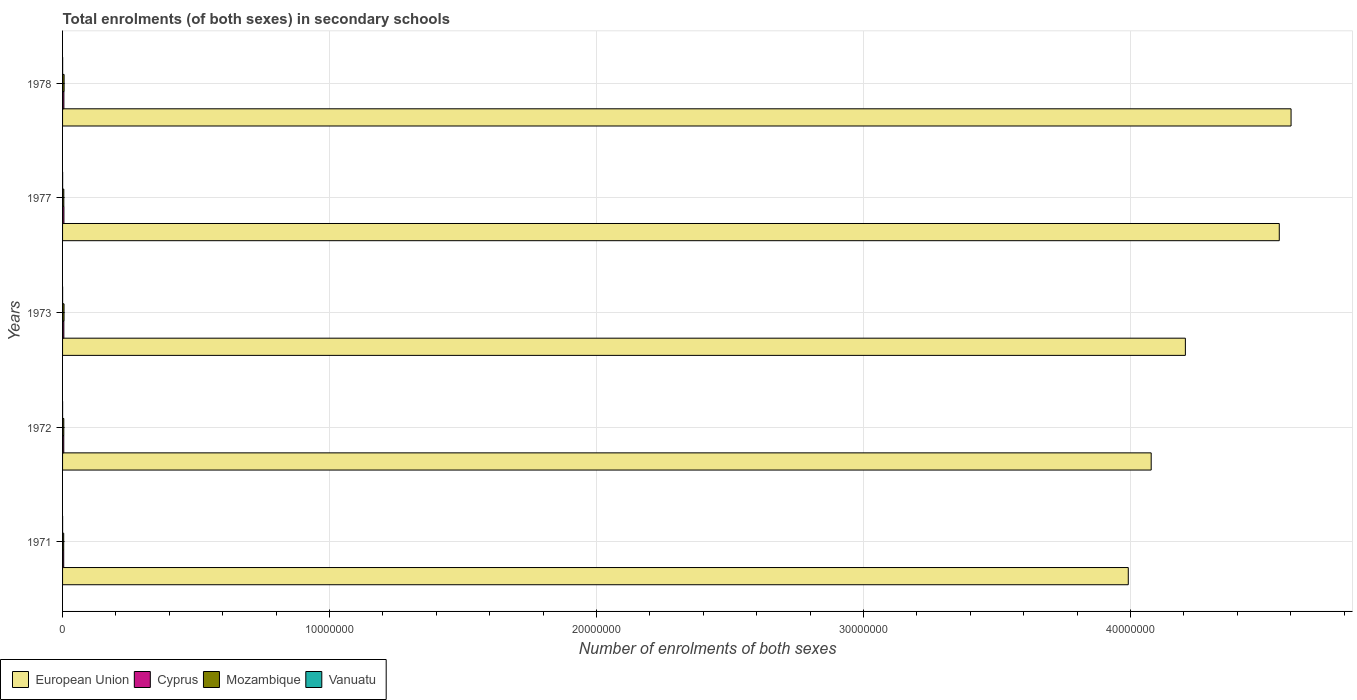How many different coloured bars are there?
Your response must be concise. 4. Are the number of bars per tick equal to the number of legend labels?
Give a very brief answer. Yes. What is the label of the 4th group of bars from the top?
Keep it short and to the point. 1972. What is the number of enrolments in secondary schools in European Union in 1971?
Provide a succinct answer. 3.99e+07. Across all years, what is the maximum number of enrolments in secondary schools in Cyprus?
Give a very brief answer. 5.06e+04. Across all years, what is the minimum number of enrolments in secondary schools in Mozambique?
Offer a terse response. 4.29e+04. In which year was the number of enrolments in secondary schools in Cyprus maximum?
Offer a very short reply. 1977. In which year was the number of enrolments in secondary schools in Mozambique minimum?
Provide a succinct answer. 1971. What is the total number of enrolments in secondary schools in European Union in the graph?
Offer a terse response. 2.14e+08. What is the difference between the number of enrolments in secondary schools in European Union in 1971 and that in 1978?
Offer a terse response. -6.10e+06. What is the difference between the number of enrolments in secondary schools in Cyprus in 1978 and the number of enrolments in secondary schools in European Union in 1973?
Offer a very short reply. -4.20e+07. What is the average number of enrolments in secondary schools in Cyprus per year?
Provide a short and direct response. 4.71e+04. In the year 1977, what is the difference between the number of enrolments in secondary schools in European Union and number of enrolments in secondary schools in Vanuatu?
Give a very brief answer. 4.56e+07. In how many years, is the number of enrolments in secondary schools in Vanuatu greater than 38000000 ?
Keep it short and to the point. 0. What is the ratio of the number of enrolments in secondary schools in Mozambique in 1971 to that in 1972?
Provide a short and direct response. 0.93. Is the number of enrolments in secondary schools in European Union in 1971 less than that in 1973?
Your answer should be compact. Yes. Is the difference between the number of enrolments in secondary schools in European Union in 1972 and 1978 greater than the difference between the number of enrolments in secondary schools in Vanuatu in 1972 and 1978?
Give a very brief answer. No. What is the difference between the highest and the second highest number of enrolments in secondary schools in Cyprus?
Your answer should be very brief. 1275. What is the difference between the highest and the lowest number of enrolments in secondary schools in Cyprus?
Offer a very short reply. 8328. Is the sum of the number of enrolments in secondary schools in Mozambique in 1977 and 1978 greater than the maximum number of enrolments in secondary schools in Cyprus across all years?
Keep it short and to the point. Yes. What does the 2nd bar from the bottom in 1972 represents?
Give a very brief answer. Cyprus. Is it the case that in every year, the sum of the number of enrolments in secondary schools in Mozambique and number of enrolments in secondary schools in Cyprus is greater than the number of enrolments in secondary schools in Vanuatu?
Ensure brevity in your answer.  Yes. Are all the bars in the graph horizontal?
Your answer should be very brief. Yes. Does the graph contain any zero values?
Ensure brevity in your answer.  No. Where does the legend appear in the graph?
Offer a terse response. Bottom left. How many legend labels are there?
Make the answer very short. 4. What is the title of the graph?
Give a very brief answer. Total enrolments (of both sexes) in secondary schools. What is the label or title of the X-axis?
Keep it short and to the point. Number of enrolments of both sexes. What is the label or title of the Y-axis?
Your response must be concise. Years. What is the Number of enrolments of both sexes in European Union in 1971?
Offer a terse response. 3.99e+07. What is the Number of enrolments of both sexes in Cyprus in 1971?
Make the answer very short. 4.23e+04. What is the Number of enrolments of both sexes in Mozambique in 1971?
Keep it short and to the point. 4.29e+04. What is the Number of enrolments of both sexes of Vanuatu in 1971?
Offer a very short reply. 878. What is the Number of enrolments of both sexes in European Union in 1972?
Keep it short and to the point. 4.08e+07. What is the Number of enrolments of both sexes in Cyprus in 1972?
Your answer should be very brief. 4.50e+04. What is the Number of enrolments of both sexes in Mozambique in 1972?
Your response must be concise. 4.61e+04. What is the Number of enrolments of both sexes of Vanuatu in 1972?
Provide a succinct answer. 980. What is the Number of enrolments of both sexes in European Union in 1973?
Your answer should be compact. 4.21e+07. What is the Number of enrolments of both sexes in Cyprus in 1973?
Ensure brevity in your answer.  4.81e+04. What is the Number of enrolments of both sexes in Mozambique in 1973?
Offer a terse response. 5.46e+04. What is the Number of enrolments of both sexes in Vanuatu in 1973?
Keep it short and to the point. 1089. What is the Number of enrolments of both sexes of European Union in 1977?
Make the answer very short. 4.56e+07. What is the Number of enrolments of both sexes of Cyprus in 1977?
Your response must be concise. 5.06e+04. What is the Number of enrolments of both sexes of Mozambique in 1977?
Offer a terse response. 4.67e+04. What is the Number of enrolments of both sexes of Vanuatu in 1977?
Provide a short and direct response. 2127. What is the Number of enrolments of both sexes in European Union in 1978?
Provide a short and direct response. 4.60e+07. What is the Number of enrolments of both sexes of Cyprus in 1978?
Make the answer very short. 4.94e+04. What is the Number of enrolments of both sexes of Mozambique in 1978?
Provide a short and direct response. 5.73e+04. What is the Number of enrolments of both sexes in Vanuatu in 1978?
Offer a terse response. 2284. Across all years, what is the maximum Number of enrolments of both sexes in European Union?
Your response must be concise. 4.60e+07. Across all years, what is the maximum Number of enrolments of both sexes of Cyprus?
Provide a succinct answer. 5.06e+04. Across all years, what is the maximum Number of enrolments of both sexes of Mozambique?
Keep it short and to the point. 5.73e+04. Across all years, what is the maximum Number of enrolments of both sexes in Vanuatu?
Your answer should be very brief. 2284. Across all years, what is the minimum Number of enrolments of both sexes of European Union?
Ensure brevity in your answer.  3.99e+07. Across all years, what is the minimum Number of enrolments of both sexes of Cyprus?
Provide a succinct answer. 4.23e+04. Across all years, what is the minimum Number of enrolments of both sexes in Mozambique?
Your response must be concise. 4.29e+04. Across all years, what is the minimum Number of enrolments of both sexes of Vanuatu?
Your answer should be very brief. 878. What is the total Number of enrolments of both sexes in European Union in the graph?
Keep it short and to the point. 2.14e+08. What is the total Number of enrolments of both sexes in Cyprus in the graph?
Make the answer very short. 2.35e+05. What is the total Number of enrolments of both sexes in Mozambique in the graph?
Your answer should be compact. 2.48e+05. What is the total Number of enrolments of both sexes of Vanuatu in the graph?
Ensure brevity in your answer.  7358. What is the difference between the Number of enrolments of both sexes of European Union in 1971 and that in 1972?
Give a very brief answer. -8.58e+05. What is the difference between the Number of enrolments of both sexes of Cyprus in 1971 and that in 1972?
Keep it short and to the point. -2736. What is the difference between the Number of enrolments of both sexes of Mozambique in 1971 and that in 1972?
Keep it short and to the point. -3260. What is the difference between the Number of enrolments of both sexes of Vanuatu in 1971 and that in 1972?
Offer a terse response. -102. What is the difference between the Number of enrolments of both sexes of European Union in 1971 and that in 1973?
Your response must be concise. -2.14e+06. What is the difference between the Number of enrolments of both sexes of Cyprus in 1971 and that in 1973?
Ensure brevity in your answer.  -5764. What is the difference between the Number of enrolments of both sexes of Mozambique in 1971 and that in 1973?
Ensure brevity in your answer.  -1.18e+04. What is the difference between the Number of enrolments of both sexes of Vanuatu in 1971 and that in 1973?
Offer a very short reply. -211. What is the difference between the Number of enrolments of both sexes of European Union in 1971 and that in 1977?
Keep it short and to the point. -5.66e+06. What is the difference between the Number of enrolments of both sexes in Cyprus in 1971 and that in 1977?
Provide a short and direct response. -8328. What is the difference between the Number of enrolments of both sexes in Mozambique in 1971 and that in 1977?
Make the answer very short. -3788. What is the difference between the Number of enrolments of both sexes in Vanuatu in 1971 and that in 1977?
Your answer should be very brief. -1249. What is the difference between the Number of enrolments of both sexes of European Union in 1971 and that in 1978?
Provide a succinct answer. -6.10e+06. What is the difference between the Number of enrolments of both sexes in Cyprus in 1971 and that in 1978?
Your answer should be compact. -7053. What is the difference between the Number of enrolments of both sexes of Mozambique in 1971 and that in 1978?
Provide a succinct answer. -1.44e+04. What is the difference between the Number of enrolments of both sexes of Vanuatu in 1971 and that in 1978?
Ensure brevity in your answer.  -1406. What is the difference between the Number of enrolments of both sexes of European Union in 1972 and that in 1973?
Provide a succinct answer. -1.28e+06. What is the difference between the Number of enrolments of both sexes in Cyprus in 1972 and that in 1973?
Your answer should be very brief. -3028. What is the difference between the Number of enrolments of both sexes in Mozambique in 1972 and that in 1973?
Offer a terse response. -8522. What is the difference between the Number of enrolments of both sexes in Vanuatu in 1972 and that in 1973?
Your response must be concise. -109. What is the difference between the Number of enrolments of both sexes of European Union in 1972 and that in 1977?
Ensure brevity in your answer.  -4.80e+06. What is the difference between the Number of enrolments of both sexes in Cyprus in 1972 and that in 1977?
Give a very brief answer. -5592. What is the difference between the Number of enrolments of both sexes of Mozambique in 1972 and that in 1977?
Provide a succinct answer. -528. What is the difference between the Number of enrolments of both sexes of Vanuatu in 1972 and that in 1977?
Your answer should be compact. -1147. What is the difference between the Number of enrolments of both sexes of European Union in 1972 and that in 1978?
Make the answer very short. -5.24e+06. What is the difference between the Number of enrolments of both sexes of Cyprus in 1972 and that in 1978?
Your answer should be compact. -4317. What is the difference between the Number of enrolments of both sexes in Mozambique in 1972 and that in 1978?
Give a very brief answer. -1.12e+04. What is the difference between the Number of enrolments of both sexes in Vanuatu in 1972 and that in 1978?
Provide a short and direct response. -1304. What is the difference between the Number of enrolments of both sexes in European Union in 1973 and that in 1977?
Make the answer very short. -3.52e+06. What is the difference between the Number of enrolments of both sexes in Cyprus in 1973 and that in 1977?
Your response must be concise. -2564. What is the difference between the Number of enrolments of both sexes of Mozambique in 1973 and that in 1977?
Offer a very short reply. 7994. What is the difference between the Number of enrolments of both sexes in Vanuatu in 1973 and that in 1977?
Offer a terse response. -1038. What is the difference between the Number of enrolments of both sexes of European Union in 1973 and that in 1978?
Offer a terse response. -3.96e+06. What is the difference between the Number of enrolments of both sexes of Cyprus in 1973 and that in 1978?
Give a very brief answer. -1289. What is the difference between the Number of enrolments of both sexes of Mozambique in 1973 and that in 1978?
Give a very brief answer. -2650. What is the difference between the Number of enrolments of both sexes of Vanuatu in 1973 and that in 1978?
Make the answer very short. -1195. What is the difference between the Number of enrolments of both sexes in European Union in 1977 and that in 1978?
Provide a succinct answer. -4.41e+05. What is the difference between the Number of enrolments of both sexes of Cyprus in 1977 and that in 1978?
Provide a succinct answer. 1275. What is the difference between the Number of enrolments of both sexes of Mozambique in 1977 and that in 1978?
Ensure brevity in your answer.  -1.06e+04. What is the difference between the Number of enrolments of both sexes in Vanuatu in 1977 and that in 1978?
Offer a terse response. -157. What is the difference between the Number of enrolments of both sexes in European Union in 1971 and the Number of enrolments of both sexes in Cyprus in 1972?
Give a very brief answer. 3.99e+07. What is the difference between the Number of enrolments of both sexes of European Union in 1971 and the Number of enrolments of both sexes of Mozambique in 1972?
Give a very brief answer. 3.99e+07. What is the difference between the Number of enrolments of both sexes in European Union in 1971 and the Number of enrolments of both sexes in Vanuatu in 1972?
Provide a short and direct response. 3.99e+07. What is the difference between the Number of enrolments of both sexes of Cyprus in 1971 and the Number of enrolments of both sexes of Mozambique in 1972?
Keep it short and to the point. -3823. What is the difference between the Number of enrolments of both sexes of Cyprus in 1971 and the Number of enrolments of both sexes of Vanuatu in 1972?
Your response must be concise. 4.13e+04. What is the difference between the Number of enrolments of both sexes of Mozambique in 1971 and the Number of enrolments of both sexes of Vanuatu in 1972?
Your answer should be compact. 4.19e+04. What is the difference between the Number of enrolments of both sexes in European Union in 1971 and the Number of enrolments of both sexes in Cyprus in 1973?
Offer a terse response. 3.99e+07. What is the difference between the Number of enrolments of both sexes in European Union in 1971 and the Number of enrolments of both sexes in Mozambique in 1973?
Provide a short and direct response. 3.99e+07. What is the difference between the Number of enrolments of both sexes of European Union in 1971 and the Number of enrolments of both sexes of Vanuatu in 1973?
Your response must be concise. 3.99e+07. What is the difference between the Number of enrolments of both sexes in Cyprus in 1971 and the Number of enrolments of both sexes in Mozambique in 1973?
Ensure brevity in your answer.  -1.23e+04. What is the difference between the Number of enrolments of both sexes of Cyprus in 1971 and the Number of enrolments of both sexes of Vanuatu in 1973?
Your answer should be very brief. 4.12e+04. What is the difference between the Number of enrolments of both sexes in Mozambique in 1971 and the Number of enrolments of both sexes in Vanuatu in 1973?
Provide a succinct answer. 4.18e+04. What is the difference between the Number of enrolments of both sexes in European Union in 1971 and the Number of enrolments of both sexes in Cyprus in 1977?
Your answer should be compact. 3.99e+07. What is the difference between the Number of enrolments of both sexes in European Union in 1971 and the Number of enrolments of both sexes in Mozambique in 1977?
Your response must be concise. 3.99e+07. What is the difference between the Number of enrolments of both sexes of European Union in 1971 and the Number of enrolments of both sexes of Vanuatu in 1977?
Offer a very short reply. 3.99e+07. What is the difference between the Number of enrolments of both sexes in Cyprus in 1971 and the Number of enrolments of both sexes in Mozambique in 1977?
Provide a short and direct response. -4351. What is the difference between the Number of enrolments of both sexes in Cyprus in 1971 and the Number of enrolments of both sexes in Vanuatu in 1977?
Your answer should be very brief. 4.02e+04. What is the difference between the Number of enrolments of both sexes in Mozambique in 1971 and the Number of enrolments of both sexes in Vanuatu in 1977?
Provide a succinct answer. 4.07e+04. What is the difference between the Number of enrolments of both sexes of European Union in 1971 and the Number of enrolments of both sexes of Cyprus in 1978?
Ensure brevity in your answer.  3.99e+07. What is the difference between the Number of enrolments of both sexes of European Union in 1971 and the Number of enrolments of both sexes of Mozambique in 1978?
Keep it short and to the point. 3.99e+07. What is the difference between the Number of enrolments of both sexes in European Union in 1971 and the Number of enrolments of both sexes in Vanuatu in 1978?
Your response must be concise. 3.99e+07. What is the difference between the Number of enrolments of both sexes in Cyprus in 1971 and the Number of enrolments of both sexes in Mozambique in 1978?
Provide a short and direct response. -1.50e+04. What is the difference between the Number of enrolments of both sexes in Cyprus in 1971 and the Number of enrolments of both sexes in Vanuatu in 1978?
Give a very brief answer. 4.00e+04. What is the difference between the Number of enrolments of both sexes of Mozambique in 1971 and the Number of enrolments of both sexes of Vanuatu in 1978?
Ensure brevity in your answer.  4.06e+04. What is the difference between the Number of enrolments of both sexes in European Union in 1972 and the Number of enrolments of both sexes in Cyprus in 1973?
Offer a terse response. 4.07e+07. What is the difference between the Number of enrolments of both sexes of European Union in 1972 and the Number of enrolments of both sexes of Mozambique in 1973?
Ensure brevity in your answer.  4.07e+07. What is the difference between the Number of enrolments of both sexes of European Union in 1972 and the Number of enrolments of both sexes of Vanuatu in 1973?
Keep it short and to the point. 4.08e+07. What is the difference between the Number of enrolments of both sexes of Cyprus in 1972 and the Number of enrolments of both sexes of Mozambique in 1973?
Your answer should be compact. -9609. What is the difference between the Number of enrolments of both sexes in Cyprus in 1972 and the Number of enrolments of both sexes in Vanuatu in 1973?
Your answer should be compact. 4.40e+04. What is the difference between the Number of enrolments of both sexes of Mozambique in 1972 and the Number of enrolments of both sexes of Vanuatu in 1973?
Provide a short and direct response. 4.50e+04. What is the difference between the Number of enrolments of both sexes of European Union in 1972 and the Number of enrolments of both sexes of Cyprus in 1977?
Keep it short and to the point. 4.07e+07. What is the difference between the Number of enrolments of both sexes in European Union in 1972 and the Number of enrolments of both sexes in Mozambique in 1977?
Offer a terse response. 4.07e+07. What is the difference between the Number of enrolments of both sexes in European Union in 1972 and the Number of enrolments of both sexes in Vanuatu in 1977?
Provide a short and direct response. 4.08e+07. What is the difference between the Number of enrolments of both sexes of Cyprus in 1972 and the Number of enrolments of both sexes of Mozambique in 1977?
Offer a very short reply. -1615. What is the difference between the Number of enrolments of both sexes in Cyprus in 1972 and the Number of enrolments of both sexes in Vanuatu in 1977?
Ensure brevity in your answer.  4.29e+04. What is the difference between the Number of enrolments of both sexes of Mozambique in 1972 and the Number of enrolments of both sexes of Vanuatu in 1977?
Keep it short and to the point. 4.40e+04. What is the difference between the Number of enrolments of both sexes in European Union in 1972 and the Number of enrolments of both sexes in Cyprus in 1978?
Offer a terse response. 4.07e+07. What is the difference between the Number of enrolments of both sexes in European Union in 1972 and the Number of enrolments of both sexes in Mozambique in 1978?
Provide a short and direct response. 4.07e+07. What is the difference between the Number of enrolments of both sexes of European Union in 1972 and the Number of enrolments of both sexes of Vanuatu in 1978?
Your response must be concise. 4.08e+07. What is the difference between the Number of enrolments of both sexes of Cyprus in 1972 and the Number of enrolments of both sexes of Mozambique in 1978?
Give a very brief answer. -1.23e+04. What is the difference between the Number of enrolments of both sexes of Cyprus in 1972 and the Number of enrolments of both sexes of Vanuatu in 1978?
Offer a very short reply. 4.28e+04. What is the difference between the Number of enrolments of both sexes in Mozambique in 1972 and the Number of enrolments of both sexes in Vanuatu in 1978?
Ensure brevity in your answer.  4.38e+04. What is the difference between the Number of enrolments of both sexes in European Union in 1973 and the Number of enrolments of both sexes in Cyprus in 1977?
Keep it short and to the point. 4.20e+07. What is the difference between the Number of enrolments of both sexes in European Union in 1973 and the Number of enrolments of both sexes in Mozambique in 1977?
Your answer should be compact. 4.20e+07. What is the difference between the Number of enrolments of both sexes of European Union in 1973 and the Number of enrolments of both sexes of Vanuatu in 1977?
Ensure brevity in your answer.  4.21e+07. What is the difference between the Number of enrolments of both sexes of Cyprus in 1973 and the Number of enrolments of both sexes of Mozambique in 1977?
Offer a terse response. 1413. What is the difference between the Number of enrolments of both sexes in Cyprus in 1973 and the Number of enrolments of both sexes in Vanuatu in 1977?
Keep it short and to the point. 4.59e+04. What is the difference between the Number of enrolments of both sexes in Mozambique in 1973 and the Number of enrolments of both sexes in Vanuatu in 1977?
Offer a terse response. 5.25e+04. What is the difference between the Number of enrolments of both sexes in European Union in 1973 and the Number of enrolments of both sexes in Cyprus in 1978?
Keep it short and to the point. 4.20e+07. What is the difference between the Number of enrolments of both sexes in European Union in 1973 and the Number of enrolments of both sexes in Mozambique in 1978?
Ensure brevity in your answer.  4.20e+07. What is the difference between the Number of enrolments of both sexes in European Union in 1973 and the Number of enrolments of both sexes in Vanuatu in 1978?
Make the answer very short. 4.21e+07. What is the difference between the Number of enrolments of both sexes of Cyprus in 1973 and the Number of enrolments of both sexes of Mozambique in 1978?
Provide a short and direct response. -9231. What is the difference between the Number of enrolments of both sexes of Cyprus in 1973 and the Number of enrolments of both sexes of Vanuatu in 1978?
Give a very brief answer. 4.58e+04. What is the difference between the Number of enrolments of both sexes of Mozambique in 1973 and the Number of enrolments of both sexes of Vanuatu in 1978?
Ensure brevity in your answer.  5.24e+04. What is the difference between the Number of enrolments of both sexes of European Union in 1977 and the Number of enrolments of both sexes of Cyprus in 1978?
Your response must be concise. 4.55e+07. What is the difference between the Number of enrolments of both sexes in European Union in 1977 and the Number of enrolments of both sexes in Mozambique in 1978?
Offer a terse response. 4.55e+07. What is the difference between the Number of enrolments of both sexes of European Union in 1977 and the Number of enrolments of both sexes of Vanuatu in 1978?
Ensure brevity in your answer.  4.56e+07. What is the difference between the Number of enrolments of both sexes of Cyprus in 1977 and the Number of enrolments of both sexes of Mozambique in 1978?
Your answer should be very brief. -6667. What is the difference between the Number of enrolments of both sexes of Cyprus in 1977 and the Number of enrolments of both sexes of Vanuatu in 1978?
Provide a short and direct response. 4.83e+04. What is the difference between the Number of enrolments of both sexes in Mozambique in 1977 and the Number of enrolments of both sexes in Vanuatu in 1978?
Your answer should be very brief. 4.44e+04. What is the average Number of enrolments of both sexes of European Union per year?
Make the answer very short. 4.29e+07. What is the average Number of enrolments of both sexes in Cyprus per year?
Provide a short and direct response. 4.71e+04. What is the average Number of enrolments of both sexes of Mozambique per year?
Give a very brief answer. 4.95e+04. What is the average Number of enrolments of both sexes of Vanuatu per year?
Ensure brevity in your answer.  1471.6. In the year 1971, what is the difference between the Number of enrolments of both sexes of European Union and Number of enrolments of both sexes of Cyprus?
Keep it short and to the point. 3.99e+07. In the year 1971, what is the difference between the Number of enrolments of both sexes in European Union and Number of enrolments of both sexes in Mozambique?
Provide a succinct answer. 3.99e+07. In the year 1971, what is the difference between the Number of enrolments of both sexes in European Union and Number of enrolments of both sexes in Vanuatu?
Keep it short and to the point. 3.99e+07. In the year 1971, what is the difference between the Number of enrolments of both sexes of Cyprus and Number of enrolments of both sexes of Mozambique?
Make the answer very short. -563. In the year 1971, what is the difference between the Number of enrolments of both sexes in Cyprus and Number of enrolments of both sexes in Vanuatu?
Your answer should be very brief. 4.14e+04. In the year 1971, what is the difference between the Number of enrolments of both sexes in Mozambique and Number of enrolments of both sexes in Vanuatu?
Your answer should be very brief. 4.20e+04. In the year 1972, what is the difference between the Number of enrolments of both sexes in European Union and Number of enrolments of both sexes in Cyprus?
Offer a very short reply. 4.07e+07. In the year 1972, what is the difference between the Number of enrolments of both sexes in European Union and Number of enrolments of both sexes in Mozambique?
Ensure brevity in your answer.  4.07e+07. In the year 1972, what is the difference between the Number of enrolments of both sexes in European Union and Number of enrolments of both sexes in Vanuatu?
Offer a terse response. 4.08e+07. In the year 1972, what is the difference between the Number of enrolments of both sexes of Cyprus and Number of enrolments of both sexes of Mozambique?
Give a very brief answer. -1087. In the year 1972, what is the difference between the Number of enrolments of both sexes in Cyprus and Number of enrolments of both sexes in Vanuatu?
Provide a short and direct response. 4.41e+04. In the year 1972, what is the difference between the Number of enrolments of both sexes of Mozambique and Number of enrolments of both sexes of Vanuatu?
Provide a succinct answer. 4.51e+04. In the year 1973, what is the difference between the Number of enrolments of both sexes in European Union and Number of enrolments of both sexes in Cyprus?
Give a very brief answer. 4.20e+07. In the year 1973, what is the difference between the Number of enrolments of both sexes of European Union and Number of enrolments of both sexes of Mozambique?
Offer a terse response. 4.20e+07. In the year 1973, what is the difference between the Number of enrolments of both sexes in European Union and Number of enrolments of both sexes in Vanuatu?
Your answer should be compact. 4.21e+07. In the year 1973, what is the difference between the Number of enrolments of both sexes of Cyprus and Number of enrolments of both sexes of Mozambique?
Your answer should be very brief. -6581. In the year 1973, what is the difference between the Number of enrolments of both sexes of Cyprus and Number of enrolments of both sexes of Vanuatu?
Offer a terse response. 4.70e+04. In the year 1973, what is the difference between the Number of enrolments of both sexes of Mozambique and Number of enrolments of both sexes of Vanuatu?
Offer a very short reply. 5.36e+04. In the year 1977, what is the difference between the Number of enrolments of both sexes in European Union and Number of enrolments of both sexes in Cyprus?
Keep it short and to the point. 4.55e+07. In the year 1977, what is the difference between the Number of enrolments of both sexes of European Union and Number of enrolments of both sexes of Mozambique?
Your answer should be very brief. 4.55e+07. In the year 1977, what is the difference between the Number of enrolments of both sexes in European Union and Number of enrolments of both sexes in Vanuatu?
Keep it short and to the point. 4.56e+07. In the year 1977, what is the difference between the Number of enrolments of both sexes in Cyprus and Number of enrolments of both sexes in Mozambique?
Offer a very short reply. 3977. In the year 1977, what is the difference between the Number of enrolments of both sexes in Cyprus and Number of enrolments of both sexes in Vanuatu?
Your answer should be very brief. 4.85e+04. In the year 1977, what is the difference between the Number of enrolments of both sexes of Mozambique and Number of enrolments of both sexes of Vanuatu?
Offer a terse response. 4.45e+04. In the year 1978, what is the difference between the Number of enrolments of both sexes of European Union and Number of enrolments of both sexes of Cyprus?
Your answer should be very brief. 4.60e+07. In the year 1978, what is the difference between the Number of enrolments of both sexes of European Union and Number of enrolments of both sexes of Mozambique?
Provide a short and direct response. 4.60e+07. In the year 1978, what is the difference between the Number of enrolments of both sexes of European Union and Number of enrolments of both sexes of Vanuatu?
Offer a terse response. 4.60e+07. In the year 1978, what is the difference between the Number of enrolments of both sexes in Cyprus and Number of enrolments of both sexes in Mozambique?
Your answer should be compact. -7942. In the year 1978, what is the difference between the Number of enrolments of both sexes of Cyprus and Number of enrolments of both sexes of Vanuatu?
Offer a terse response. 4.71e+04. In the year 1978, what is the difference between the Number of enrolments of both sexes in Mozambique and Number of enrolments of both sexes in Vanuatu?
Give a very brief answer. 5.50e+04. What is the ratio of the Number of enrolments of both sexes in Cyprus in 1971 to that in 1972?
Offer a terse response. 0.94. What is the ratio of the Number of enrolments of both sexes in Mozambique in 1971 to that in 1972?
Give a very brief answer. 0.93. What is the ratio of the Number of enrolments of both sexes of Vanuatu in 1971 to that in 1972?
Offer a very short reply. 0.9. What is the ratio of the Number of enrolments of both sexes of European Union in 1971 to that in 1973?
Make the answer very short. 0.95. What is the ratio of the Number of enrolments of both sexes in Cyprus in 1971 to that in 1973?
Your answer should be very brief. 0.88. What is the ratio of the Number of enrolments of both sexes of Mozambique in 1971 to that in 1973?
Your answer should be compact. 0.78. What is the ratio of the Number of enrolments of both sexes in Vanuatu in 1971 to that in 1973?
Give a very brief answer. 0.81. What is the ratio of the Number of enrolments of both sexes in European Union in 1971 to that in 1977?
Keep it short and to the point. 0.88. What is the ratio of the Number of enrolments of both sexes in Cyprus in 1971 to that in 1977?
Offer a very short reply. 0.84. What is the ratio of the Number of enrolments of both sexes of Mozambique in 1971 to that in 1977?
Offer a terse response. 0.92. What is the ratio of the Number of enrolments of both sexes in Vanuatu in 1971 to that in 1977?
Offer a very short reply. 0.41. What is the ratio of the Number of enrolments of both sexes of European Union in 1971 to that in 1978?
Offer a very short reply. 0.87. What is the ratio of the Number of enrolments of both sexes in Cyprus in 1971 to that in 1978?
Provide a succinct answer. 0.86. What is the ratio of the Number of enrolments of both sexes in Mozambique in 1971 to that in 1978?
Offer a very short reply. 0.75. What is the ratio of the Number of enrolments of both sexes of Vanuatu in 1971 to that in 1978?
Make the answer very short. 0.38. What is the ratio of the Number of enrolments of both sexes of European Union in 1972 to that in 1973?
Your answer should be compact. 0.97. What is the ratio of the Number of enrolments of both sexes of Cyprus in 1972 to that in 1973?
Offer a very short reply. 0.94. What is the ratio of the Number of enrolments of both sexes in Mozambique in 1972 to that in 1973?
Provide a succinct answer. 0.84. What is the ratio of the Number of enrolments of both sexes in Vanuatu in 1972 to that in 1973?
Provide a succinct answer. 0.9. What is the ratio of the Number of enrolments of both sexes of European Union in 1972 to that in 1977?
Ensure brevity in your answer.  0.89. What is the ratio of the Number of enrolments of both sexes of Cyprus in 1972 to that in 1977?
Your response must be concise. 0.89. What is the ratio of the Number of enrolments of both sexes of Mozambique in 1972 to that in 1977?
Provide a succinct answer. 0.99. What is the ratio of the Number of enrolments of both sexes of Vanuatu in 1972 to that in 1977?
Make the answer very short. 0.46. What is the ratio of the Number of enrolments of both sexes in European Union in 1972 to that in 1978?
Your answer should be compact. 0.89. What is the ratio of the Number of enrolments of both sexes of Cyprus in 1972 to that in 1978?
Your answer should be compact. 0.91. What is the ratio of the Number of enrolments of both sexes in Mozambique in 1972 to that in 1978?
Keep it short and to the point. 0.81. What is the ratio of the Number of enrolments of both sexes in Vanuatu in 1972 to that in 1978?
Make the answer very short. 0.43. What is the ratio of the Number of enrolments of both sexes of European Union in 1973 to that in 1977?
Offer a terse response. 0.92. What is the ratio of the Number of enrolments of both sexes of Cyprus in 1973 to that in 1977?
Offer a terse response. 0.95. What is the ratio of the Number of enrolments of both sexes of Mozambique in 1973 to that in 1977?
Ensure brevity in your answer.  1.17. What is the ratio of the Number of enrolments of both sexes in Vanuatu in 1973 to that in 1977?
Keep it short and to the point. 0.51. What is the ratio of the Number of enrolments of both sexes in European Union in 1973 to that in 1978?
Ensure brevity in your answer.  0.91. What is the ratio of the Number of enrolments of both sexes of Cyprus in 1973 to that in 1978?
Your response must be concise. 0.97. What is the ratio of the Number of enrolments of both sexes of Mozambique in 1973 to that in 1978?
Give a very brief answer. 0.95. What is the ratio of the Number of enrolments of both sexes in Vanuatu in 1973 to that in 1978?
Give a very brief answer. 0.48. What is the ratio of the Number of enrolments of both sexes of European Union in 1977 to that in 1978?
Offer a very short reply. 0.99. What is the ratio of the Number of enrolments of both sexes of Cyprus in 1977 to that in 1978?
Your answer should be compact. 1.03. What is the ratio of the Number of enrolments of both sexes in Mozambique in 1977 to that in 1978?
Keep it short and to the point. 0.81. What is the ratio of the Number of enrolments of both sexes of Vanuatu in 1977 to that in 1978?
Provide a short and direct response. 0.93. What is the difference between the highest and the second highest Number of enrolments of both sexes of European Union?
Your answer should be compact. 4.41e+05. What is the difference between the highest and the second highest Number of enrolments of both sexes of Cyprus?
Keep it short and to the point. 1275. What is the difference between the highest and the second highest Number of enrolments of both sexes in Mozambique?
Your answer should be compact. 2650. What is the difference between the highest and the second highest Number of enrolments of both sexes of Vanuatu?
Give a very brief answer. 157. What is the difference between the highest and the lowest Number of enrolments of both sexes in European Union?
Give a very brief answer. 6.10e+06. What is the difference between the highest and the lowest Number of enrolments of both sexes of Cyprus?
Offer a terse response. 8328. What is the difference between the highest and the lowest Number of enrolments of both sexes in Mozambique?
Offer a terse response. 1.44e+04. What is the difference between the highest and the lowest Number of enrolments of both sexes of Vanuatu?
Give a very brief answer. 1406. 